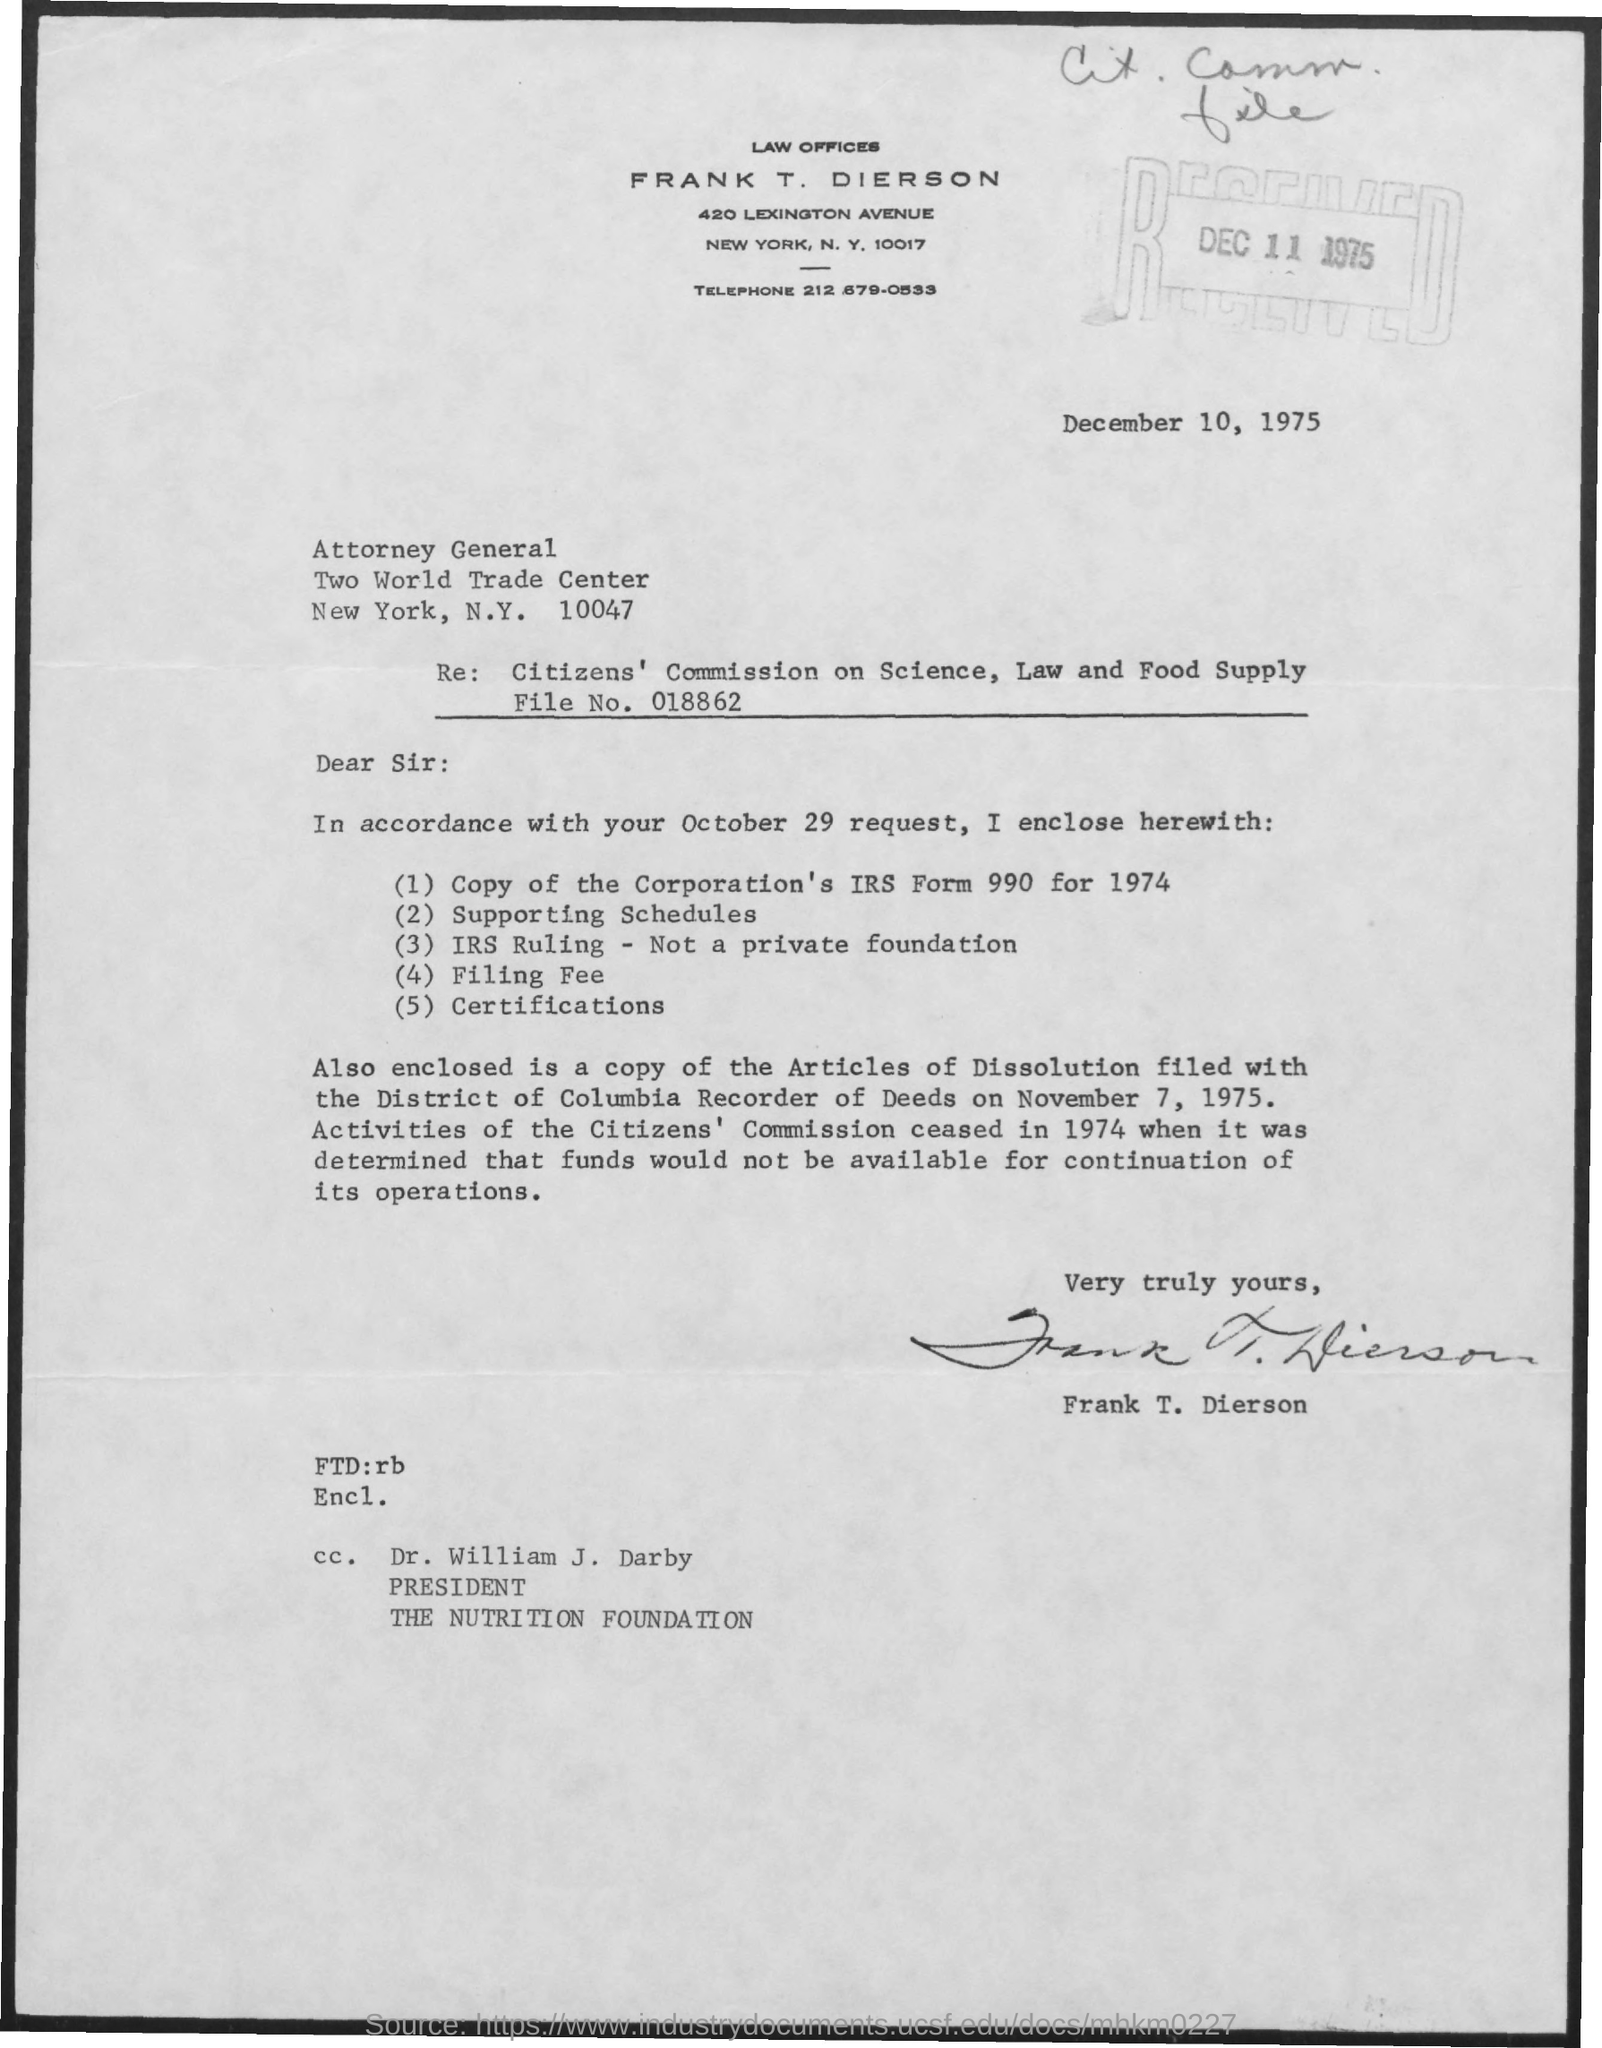Mention a couple of crucial points in this snapshot. Dr. William J. Darby is mentioned in the cc. Dr. William J. Darby holds the designation of President. The file number mentioned in the subject line of the email is 018862. The telephone number mentioned is 212-679-0533. The author of this letter is Frank T. Dierson. 